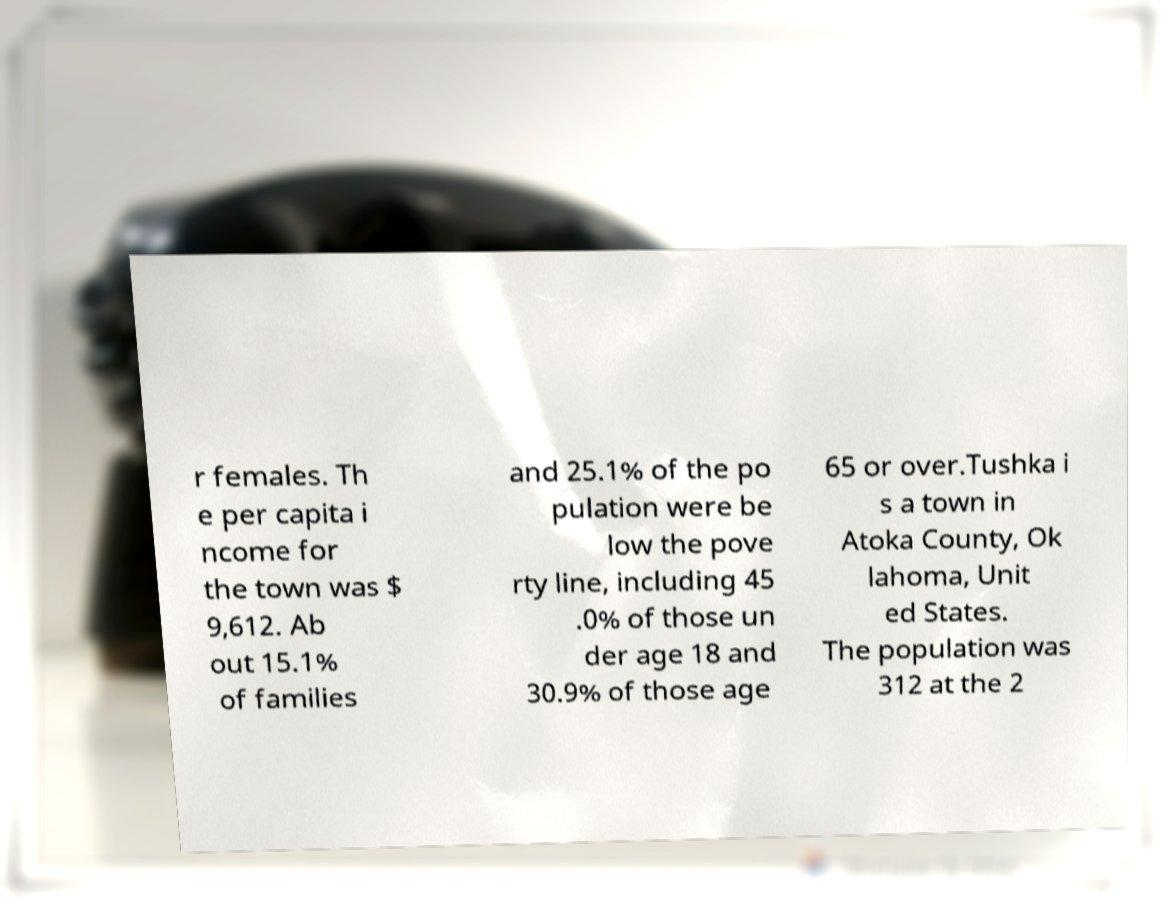Can you accurately transcribe the text from the provided image for me? r females. Th e per capita i ncome for the town was $ 9,612. Ab out 15.1% of families and 25.1% of the po pulation were be low the pove rty line, including 45 .0% of those un der age 18 and 30.9% of those age 65 or over.Tushka i s a town in Atoka County, Ok lahoma, Unit ed States. The population was 312 at the 2 